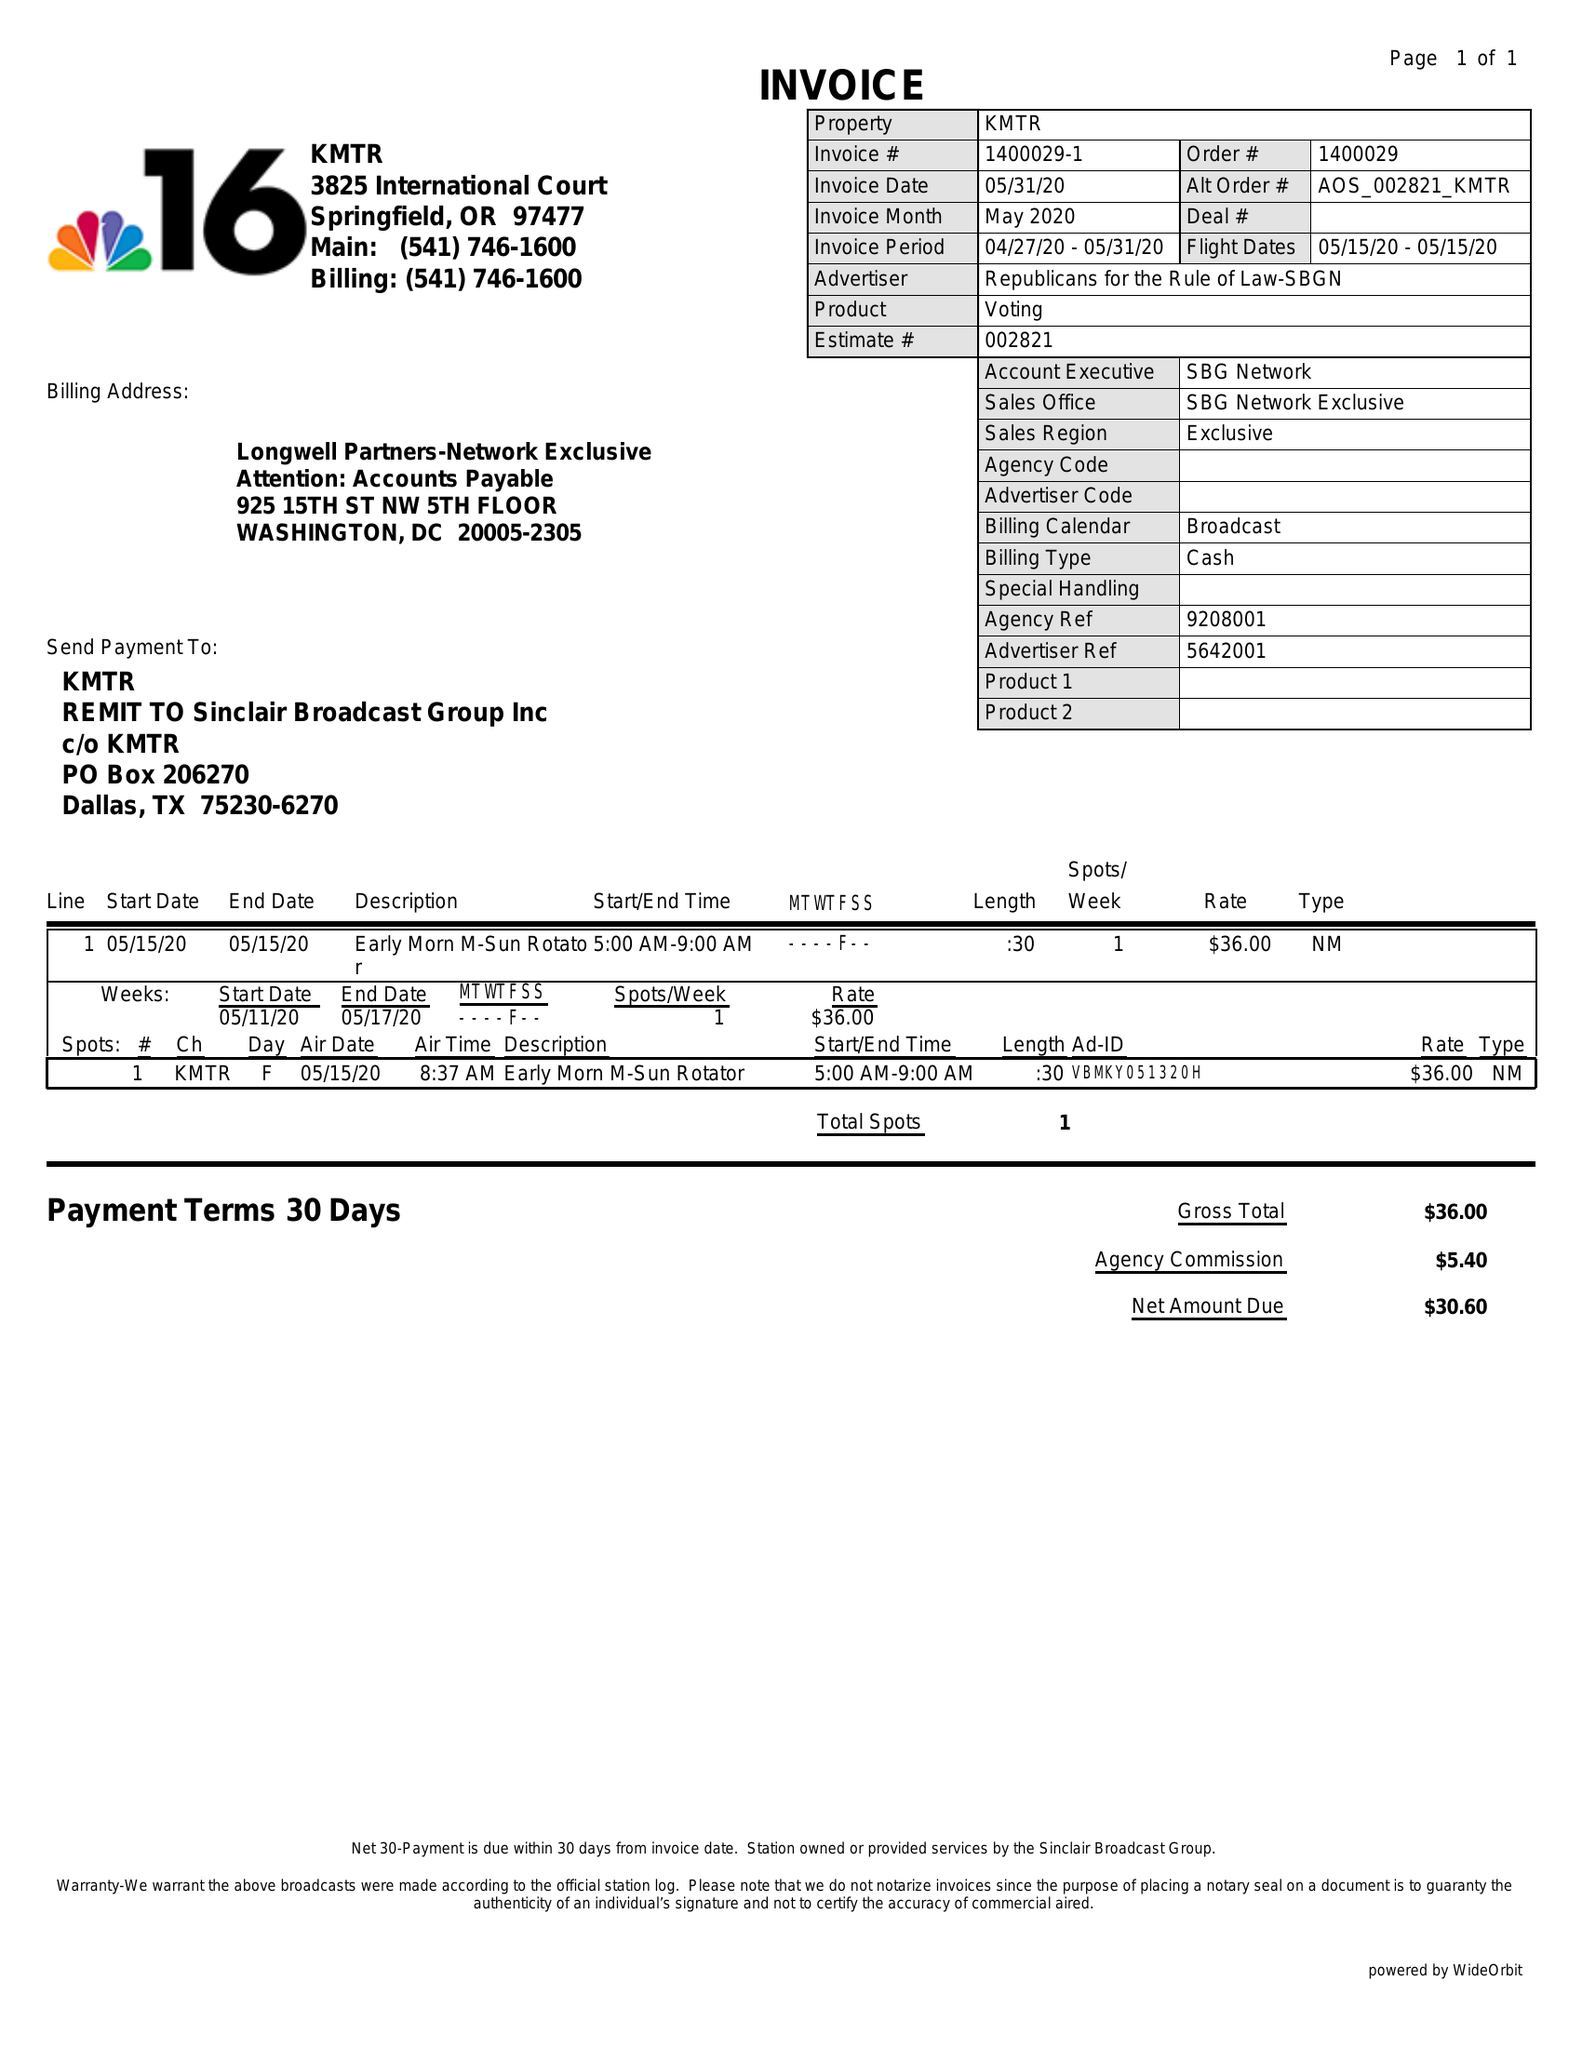What is the value for the flight_to?
Answer the question using a single word or phrase. 05/15/20 